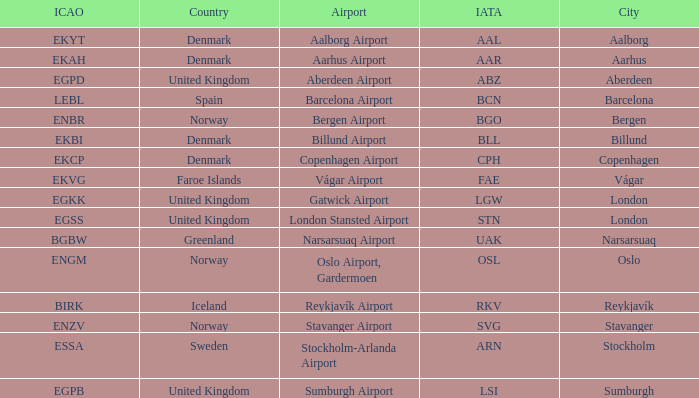What is the ICAO for Denmark, and the IATA is bll? EKBI. 